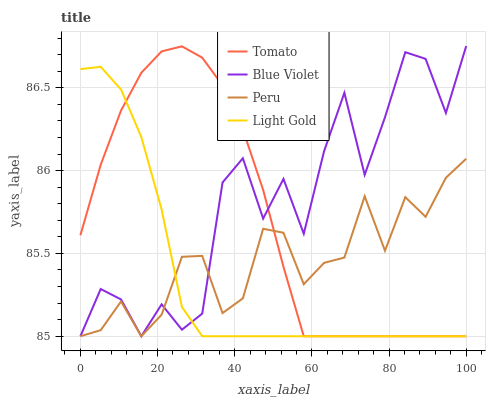Does Light Gold have the minimum area under the curve?
Answer yes or no. Yes. Does Blue Violet have the maximum area under the curve?
Answer yes or no. Yes. Does Peru have the minimum area under the curve?
Answer yes or no. No. Does Peru have the maximum area under the curve?
Answer yes or no. No. Is Light Gold the smoothest?
Answer yes or no. Yes. Is Blue Violet the roughest?
Answer yes or no. Yes. Is Peru the smoothest?
Answer yes or no. No. Is Peru the roughest?
Answer yes or no. No. Does Tomato have the lowest value?
Answer yes or no. Yes. Does Blue Violet have the highest value?
Answer yes or no. Yes. Does Light Gold have the highest value?
Answer yes or no. No. Does Peru intersect Tomato?
Answer yes or no. Yes. Is Peru less than Tomato?
Answer yes or no. No. Is Peru greater than Tomato?
Answer yes or no. No. 